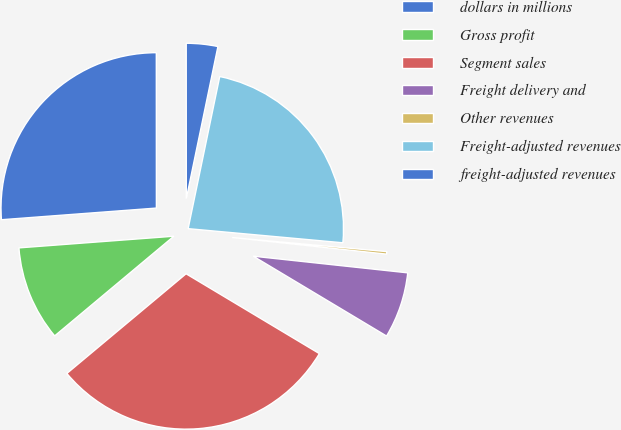Convert chart. <chart><loc_0><loc_0><loc_500><loc_500><pie_chart><fcel>dollars in millions<fcel>Gross profit<fcel>Segment sales<fcel>Freight delivery and<fcel>Other revenues<fcel>Freight-adjusted revenues<fcel>freight-adjusted revenues<nl><fcel>26.19%<fcel>9.89%<fcel>30.33%<fcel>6.88%<fcel>0.26%<fcel>23.19%<fcel>3.27%<nl></chart> 